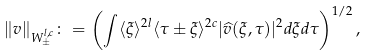Convert formula to latex. <formula><loc_0><loc_0><loc_500><loc_500>\| v \| _ { W _ { \pm } ^ { l , c } } \colon = \left ( \int \langle \xi \rangle ^ { 2 l } \langle \tau \pm \xi \rangle ^ { 2 c } | \widehat { v } ( \xi , \tau ) | ^ { 2 } d \xi d \tau \right ) ^ { 1 / 2 } ,</formula> 